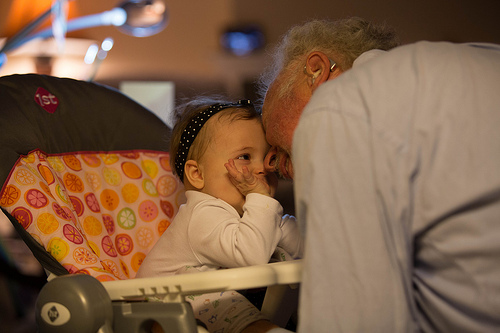<image>
Is there a baby behind the man? No. The baby is not behind the man. From this viewpoint, the baby appears to be positioned elsewhere in the scene. 